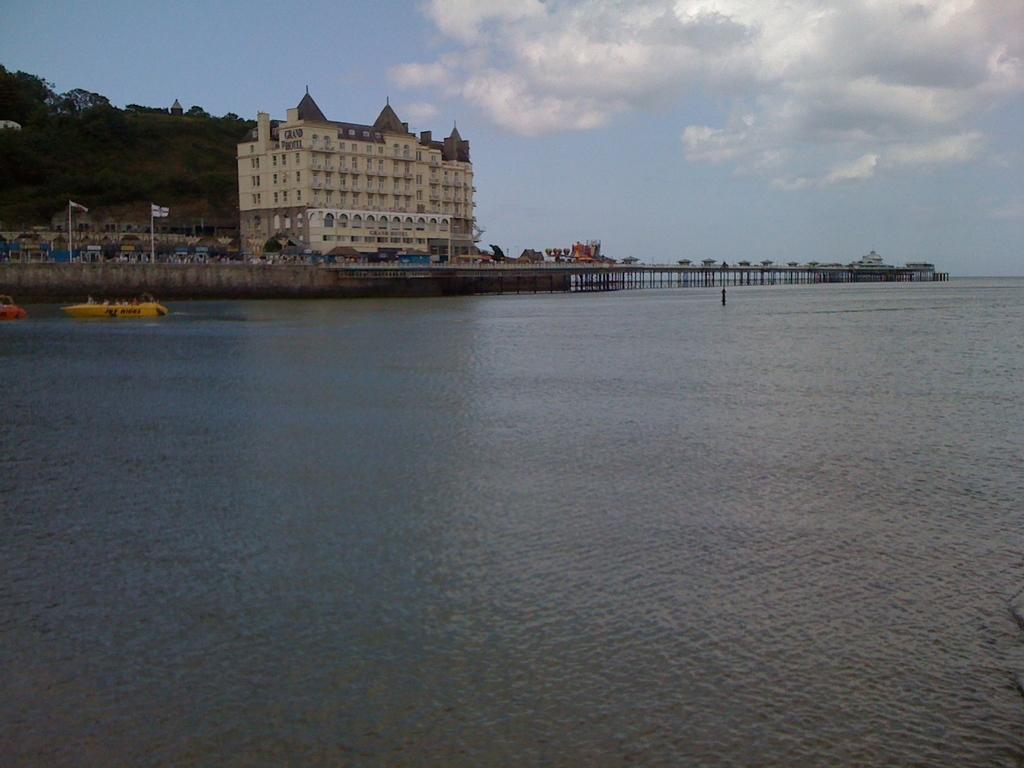Could you give a brief overview of what you see in this image? In this picture we can see a beautiful view of the river water in the front. Behind there is a bridge and brown building. In the background we can see a hilly area full of trees. On the top we can see the sky and clouds. 